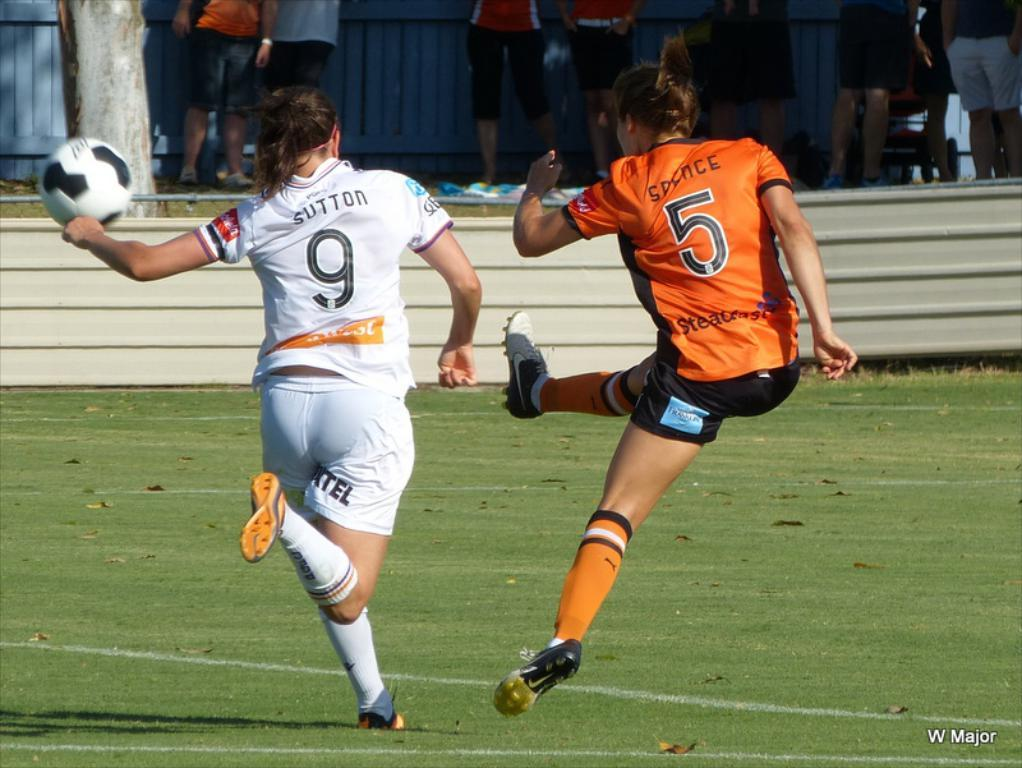Provide a one-sentence caption for the provided image. A female soccer player in white with Sutton 9 on her jersey chases a ball kicked by a player in an orange jersey with the number 5 on it. 